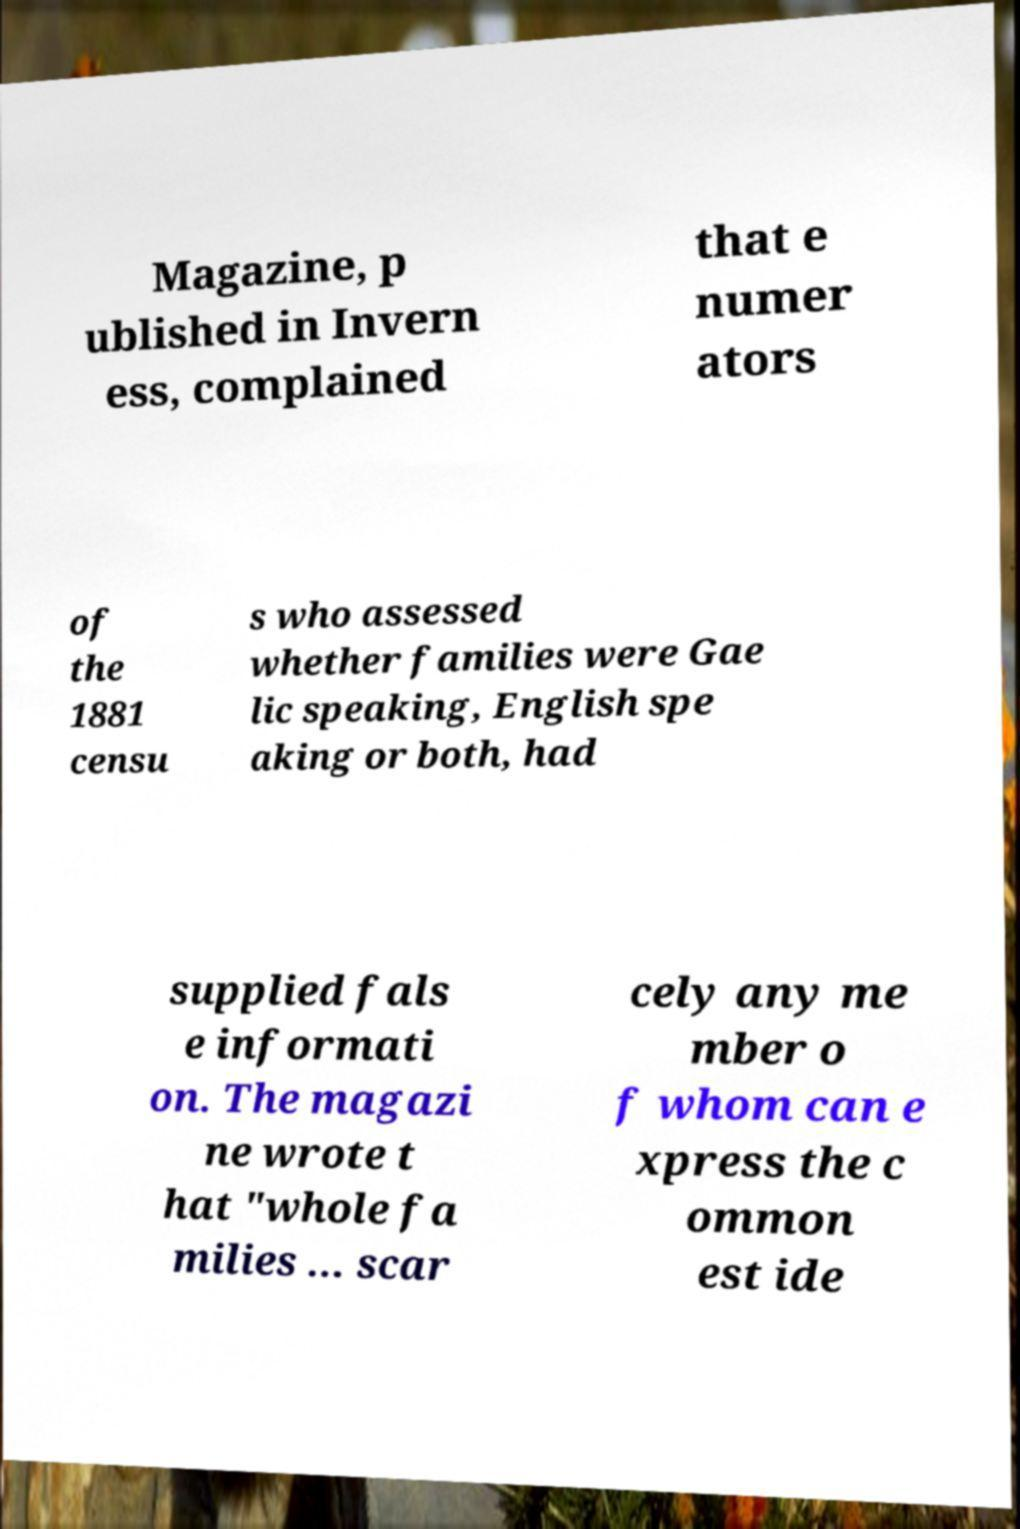Could you assist in decoding the text presented in this image and type it out clearly? Magazine, p ublished in Invern ess, complained that e numer ators of the 1881 censu s who assessed whether families were Gae lic speaking, English spe aking or both, had supplied fals e informati on. The magazi ne wrote t hat "whole fa milies ... scar cely any me mber o f whom can e xpress the c ommon est ide 